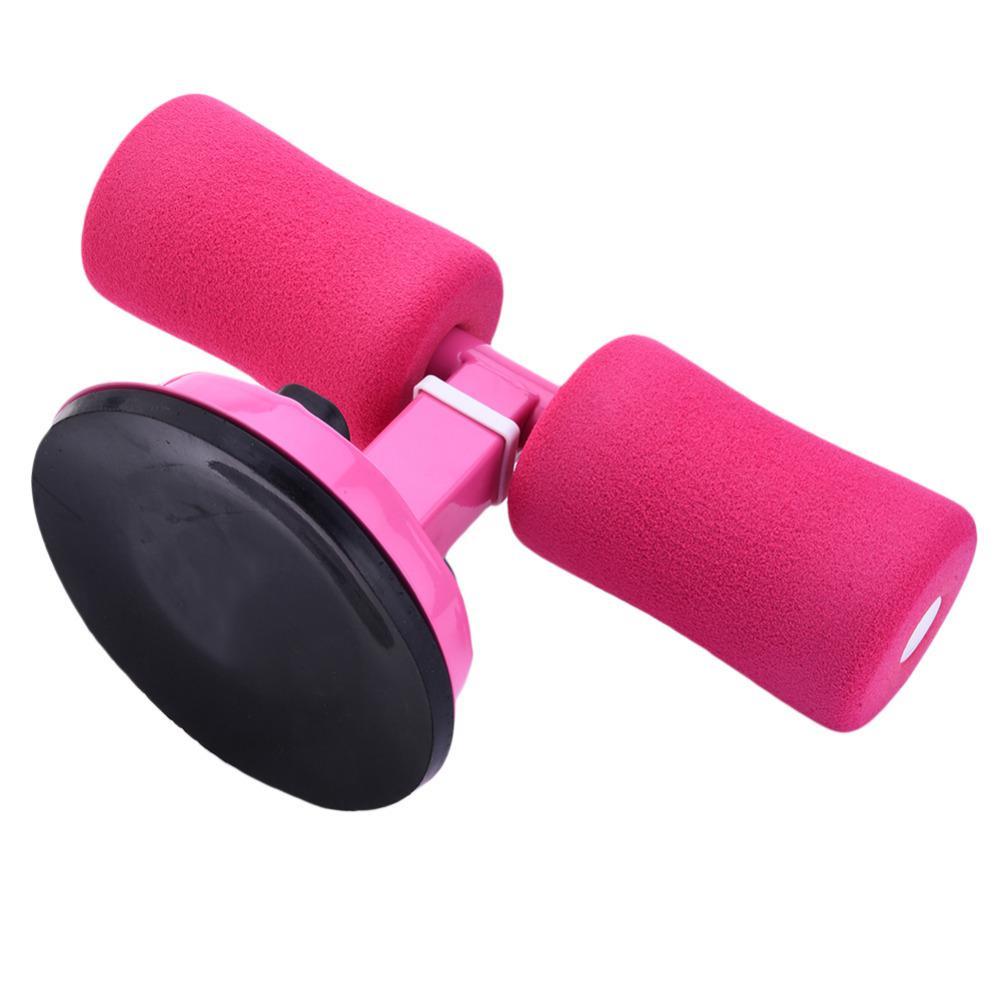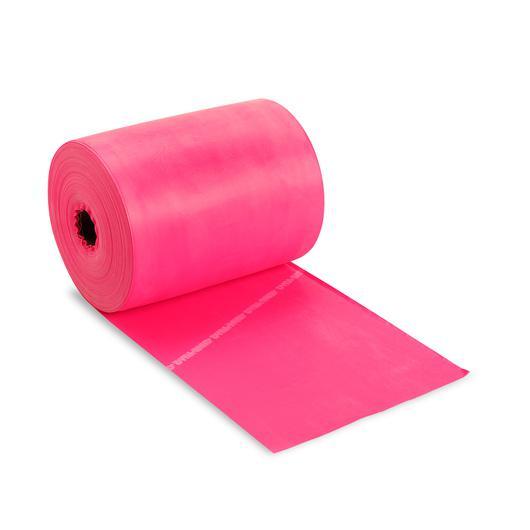The first image is the image on the left, the second image is the image on the right. Assess this claim about the two images: "In each image, one dumbbell is leaning against another.". Correct or not? Answer yes or no. No. The first image is the image on the left, the second image is the image on the right. For the images shown, is this caption "There are four dumbbells." true? Answer yes or no. No. 